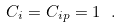Convert formula to latex. <formula><loc_0><loc_0><loc_500><loc_500>C _ { i } = C _ { i p } = 1 \ .</formula> 